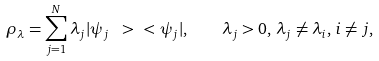<formula> <loc_0><loc_0><loc_500><loc_500>\rho _ { \lambda } = \sum _ { j = 1 } ^ { N } \lambda _ { j } | \psi _ { j } \ > \ < \psi _ { j } | , \quad \lambda _ { j } > 0 , \, \lambda _ { j } \neq \lambda _ { i } , \, i \neq j ,</formula> 